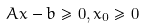Convert formula to latex. <formula><loc_0><loc_0><loc_500><loc_500>A x - b \geq 0 , x _ { 0 } \geq 0</formula> 